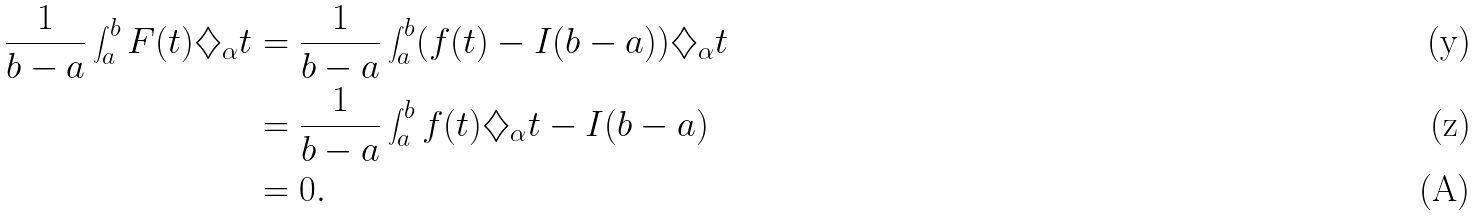Convert formula to latex. <formula><loc_0><loc_0><loc_500><loc_500>\frac { 1 } { b - a } \int _ { a } ^ { b } F ( t ) \diamondsuit _ { \alpha } t & = \frac { 1 } { b - a } \int _ { a } ^ { b } ( f ( t ) - I ( b - a ) ) \diamondsuit _ { \alpha } t \\ & = \frac { 1 } { b - a } \int _ { a } ^ { b } f ( t ) \diamondsuit _ { \alpha } t - I ( b - a ) \\ & = 0 .</formula> 